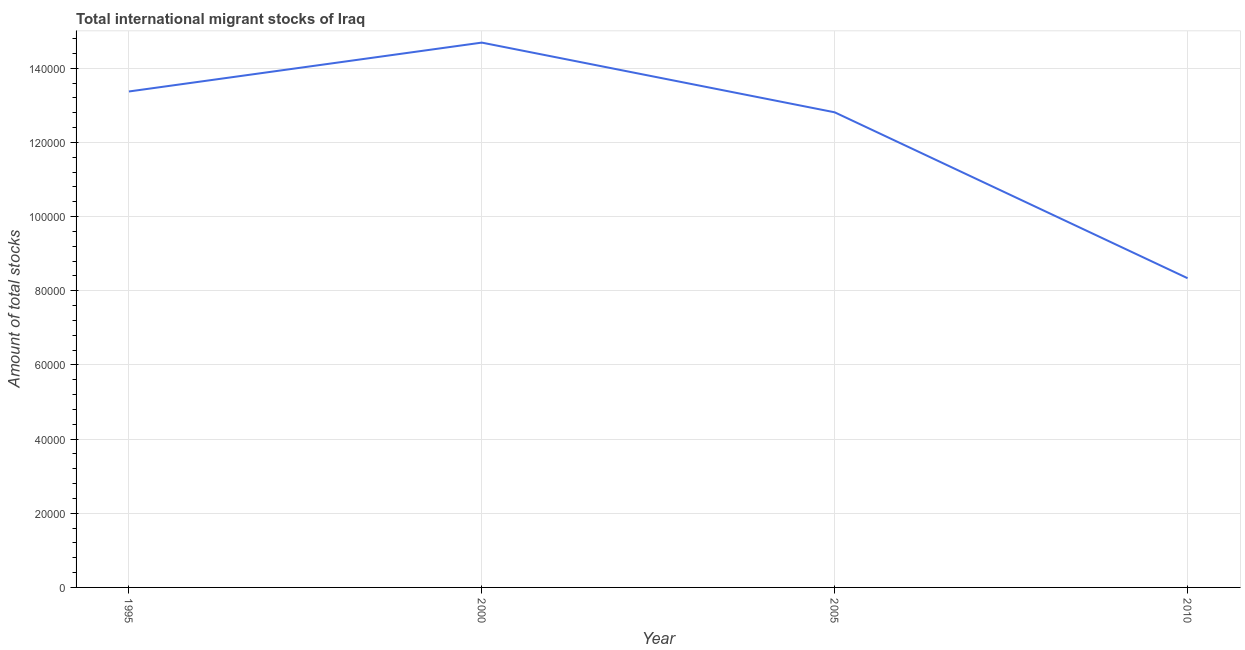What is the total number of international migrant stock in 1995?
Keep it short and to the point. 1.34e+05. Across all years, what is the maximum total number of international migrant stock?
Offer a terse response. 1.47e+05. Across all years, what is the minimum total number of international migrant stock?
Your answer should be very brief. 8.34e+04. In which year was the total number of international migrant stock minimum?
Offer a very short reply. 2010. What is the sum of the total number of international migrant stock?
Ensure brevity in your answer.  4.92e+05. What is the difference between the total number of international migrant stock in 2000 and 2010?
Give a very brief answer. 6.35e+04. What is the average total number of international migrant stock per year?
Your answer should be compact. 1.23e+05. What is the median total number of international migrant stock?
Keep it short and to the point. 1.31e+05. Do a majority of the years between 1995 and 2000 (inclusive) have total number of international migrant stock greater than 120000 ?
Keep it short and to the point. Yes. What is the ratio of the total number of international migrant stock in 1995 to that in 2000?
Give a very brief answer. 0.91. Is the total number of international migrant stock in 2000 less than that in 2005?
Offer a terse response. No. Is the difference between the total number of international migrant stock in 2005 and 2010 greater than the difference between any two years?
Your answer should be very brief. No. What is the difference between the highest and the second highest total number of international migrant stock?
Offer a very short reply. 1.32e+04. What is the difference between the highest and the lowest total number of international migrant stock?
Make the answer very short. 6.35e+04. Does the total number of international migrant stock monotonically increase over the years?
Your response must be concise. No. How many years are there in the graph?
Your answer should be very brief. 4. Does the graph contain any zero values?
Your answer should be compact. No. Does the graph contain grids?
Offer a very short reply. Yes. What is the title of the graph?
Your response must be concise. Total international migrant stocks of Iraq. What is the label or title of the X-axis?
Make the answer very short. Year. What is the label or title of the Y-axis?
Offer a terse response. Amount of total stocks. What is the Amount of total stocks of 1995?
Your answer should be compact. 1.34e+05. What is the Amount of total stocks of 2000?
Your answer should be very brief. 1.47e+05. What is the Amount of total stocks in 2005?
Provide a short and direct response. 1.28e+05. What is the Amount of total stocks of 2010?
Offer a terse response. 8.34e+04. What is the difference between the Amount of total stocks in 1995 and 2000?
Keep it short and to the point. -1.32e+04. What is the difference between the Amount of total stocks in 1995 and 2005?
Your response must be concise. 5618. What is the difference between the Amount of total stocks in 1995 and 2010?
Provide a short and direct response. 5.04e+04. What is the difference between the Amount of total stocks in 2000 and 2005?
Keep it short and to the point. 1.88e+04. What is the difference between the Amount of total stocks in 2000 and 2010?
Make the answer very short. 6.35e+04. What is the difference between the Amount of total stocks in 2005 and 2010?
Provide a succinct answer. 4.47e+04. What is the ratio of the Amount of total stocks in 1995 to that in 2000?
Provide a short and direct response. 0.91. What is the ratio of the Amount of total stocks in 1995 to that in 2005?
Offer a terse response. 1.04. What is the ratio of the Amount of total stocks in 1995 to that in 2010?
Keep it short and to the point. 1.6. What is the ratio of the Amount of total stocks in 2000 to that in 2005?
Give a very brief answer. 1.15. What is the ratio of the Amount of total stocks in 2000 to that in 2010?
Offer a terse response. 1.76. What is the ratio of the Amount of total stocks in 2005 to that in 2010?
Your answer should be very brief. 1.54. 